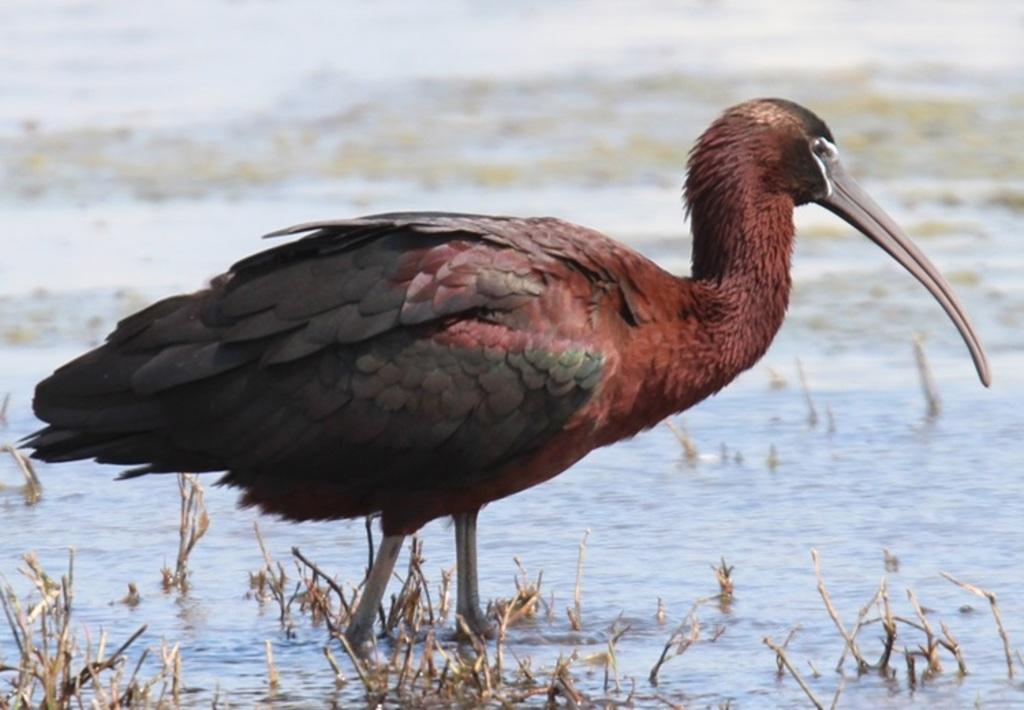In one or two sentences, can you explain what this image depicts? In the picture I can see a bird which is in black and maroon color is standing in the water. Here we can see dry plants and the background of the image is slightly blurred. 